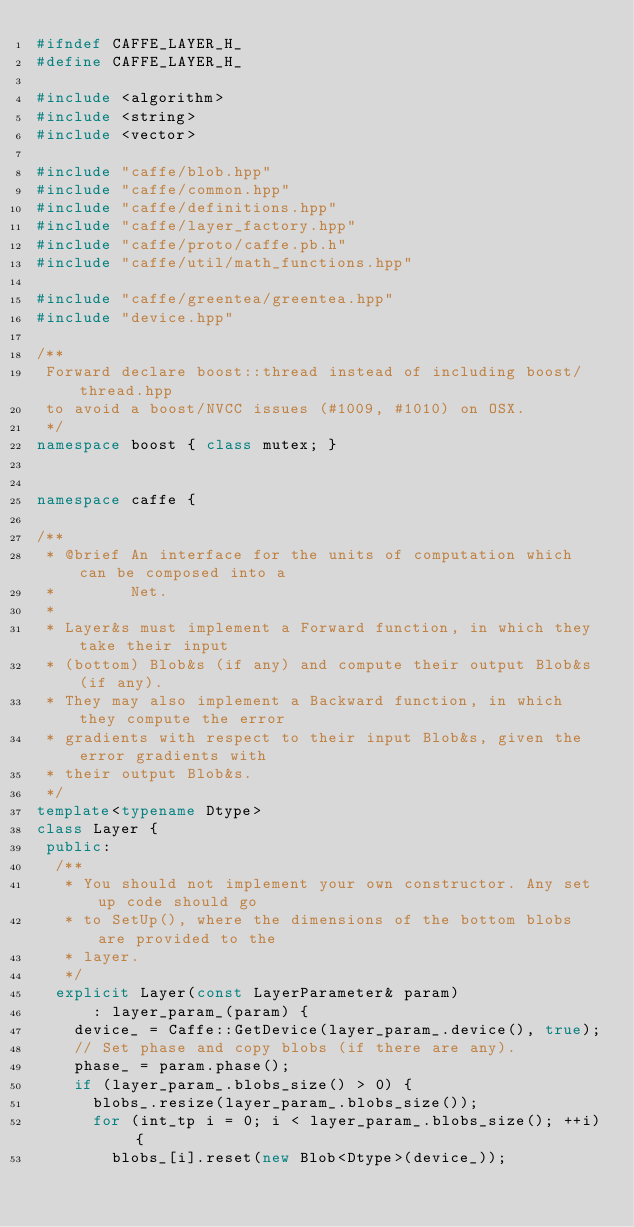<code> <loc_0><loc_0><loc_500><loc_500><_C++_>#ifndef CAFFE_LAYER_H_
#define CAFFE_LAYER_H_

#include <algorithm>
#include <string>
#include <vector>

#include "caffe/blob.hpp"
#include "caffe/common.hpp"
#include "caffe/definitions.hpp"
#include "caffe/layer_factory.hpp"
#include "caffe/proto/caffe.pb.h"
#include "caffe/util/math_functions.hpp"

#include "caffe/greentea/greentea.hpp"
#include "device.hpp"

/**
 Forward declare boost::thread instead of including boost/thread.hpp
 to avoid a boost/NVCC issues (#1009, #1010) on OSX.
 */
namespace boost { class mutex; }


namespace caffe {

/**
 * @brief An interface for the units of computation which can be composed into a
 *        Net.
 *
 * Layer&s must implement a Forward function, in which they take their input
 * (bottom) Blob&s (if any) and compute their output Blob&s (if any).
 * They may also implement a Backward function, in which they compute the error
 * gradients with respect to their input Blob&s, given the error gradients with
 * their output Blob&s.
 */
template<typename Dtype>
class Layer {
 public:
  /**
   * You should not implement your own constructor. Any set up code should go
   * to SetUp(), where the dimensions of the bottom blobs are provided to the
   * layer.
   */
  explicit Layer(const LayerParameter& param)
      : layer_param_(param) {
    device_ = Caffe::GetDevice(layer_param_.device(), true);
    // Set phase and copy blobs (if there are any).
    phase_ = param.phase();
    if (layer_param_.blobs_size() > 0) {
      blobs_.resize(layer_param_.blobs_size());
      for (int_tp i = 0; i < layer_param_.blobs_size(); ++i) {
        blobs_[i].reset(new Blob<Dtype>(device_));</code> 